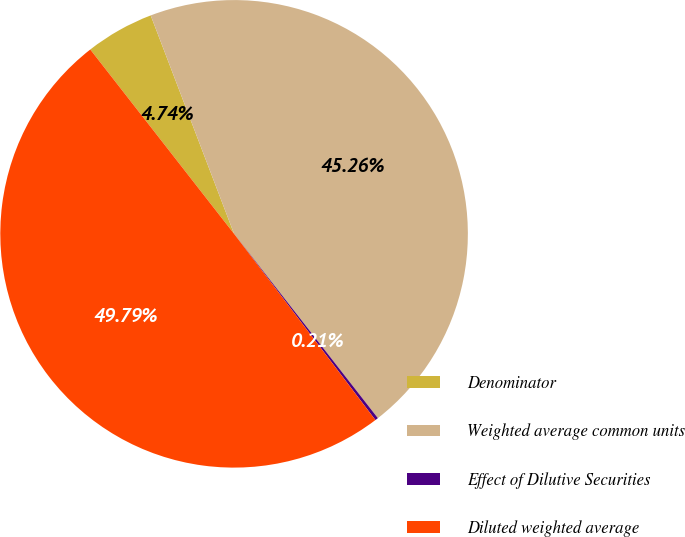Convert chart to OTSL. <chart><loc_0><loc_0><loc_500><loc_500><pie_chart><fcel>Denominator<fcel>Weighted average common units<fcel>Effect of Dilutive Securities<fcel>Diluted weighted average<nl><fcel>4.74%<fcel>45.26%<fcel>0.21%<fcel>49.79%<nl></chart> 